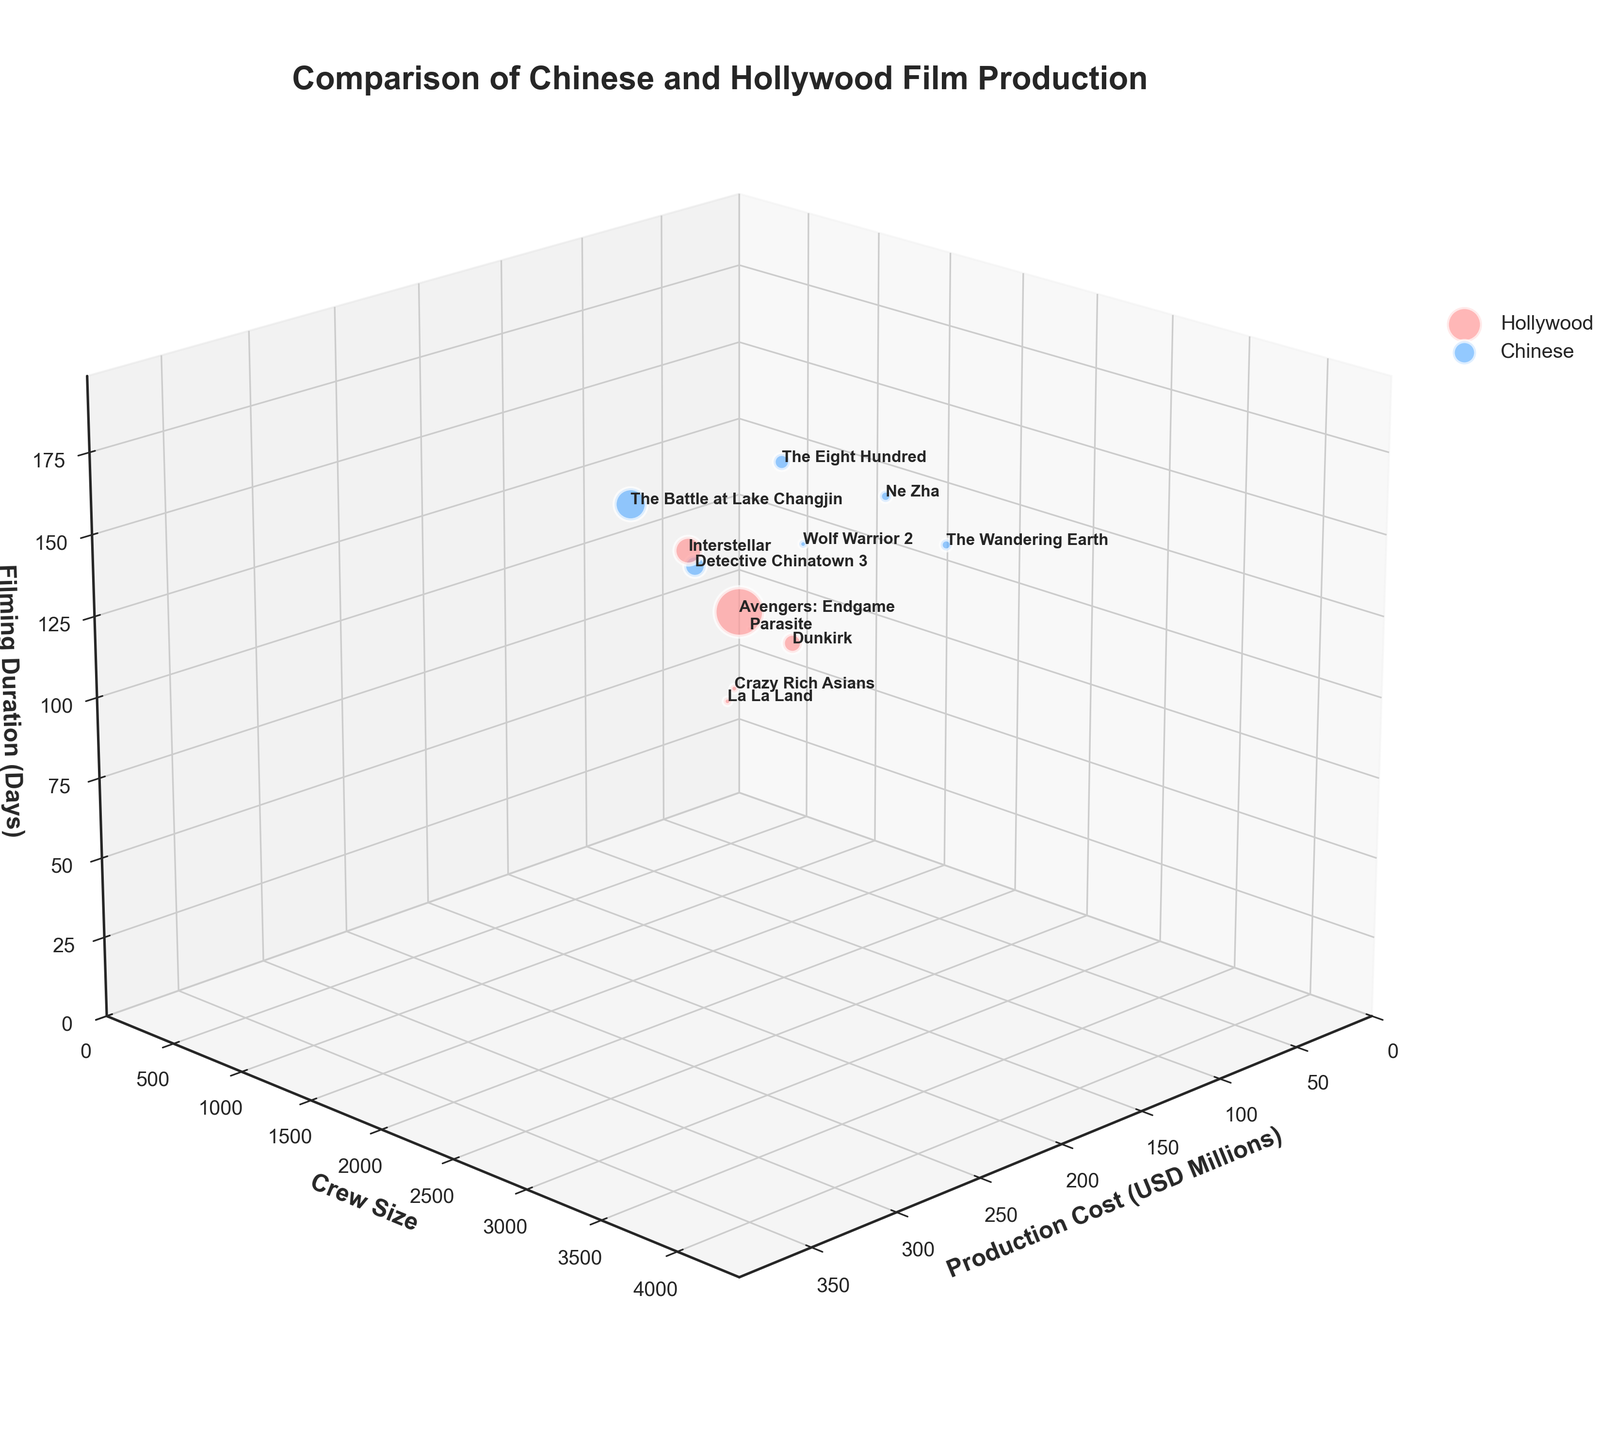What is the title of the figure? The title is usually displayed at the top of the figure. By looking at the top, we can see the title "Comparison of Chinese and Hollywood Film Production".
Answer: Comparison of Chinese and Hollywood Film Production What do the axes represent? Each of the three axes is labeled with their respective dimensions, visible at their bases or along the lines. The x-axis is labeled "Production Cost (USD Millions)", the y-axis is labeled "Crew Size", and the z-axis is labeled "Filming Duration (Days)".
Answer: Production Cost (USD Millions), Crew Size, Filming Duration (Days) How many bubbles represent Hollywood films? The number of data points (bubbles) can be counted based on the color that represents Hollywood films. The Hollywood films are represented by one specific color, and there are 6 such bubbles.
Answer: 6 Which film has the highest production cost? To determine the film with the highest production cost, identify the largest x-axis value among the bubbles. "Avengers: Endgame" has the highest value on the x-axis at 356 USD Millions.
Answer: Avengers: Endgame What is the crew size for "The Wandering Earth"? Locate the bubble labeled "The Wandering Earth" and reference its y-axis position. The label next to this bubble indicates it has a crew size of 2000.
Answer: 2000 How does the crew size of "Dunkirk" compare to "Crazy Rich Asians"? Locate the bubbles for "Dunkirk" and "Crazy Rich Asians" and compare their y-axis positions. "Dunkirk" has a crew size of 1500, and "Crazy Rich Asians" has a crew size of 300.
Answer: "Dunkirk" has a larger crew size than "Crazy Rich Asians" What is the average filming duration of all Chinese films? Identify all Chinese films and sum their filming durations (120 + 150 + 130 + 140 + 100 + 110 = 750). Divide this sum by the number of Chinese films (6). So, the average is 750/6 = 125.
Answer: 125 days Which film has the largest bubble size, and what does that signify? The size of the bubble corresponds to the production cost. The largest bubble belongs to "Avengers: Endgame", indicating it has the highest production cost among the films.
Answer: Avengers: Endgame; Highest Production Cost Which film in the Hollywood industry has the shortest filming duration? Find the Hollywood film bubble with the smallest value on the z-axis. "La La Land" has the shortest filming duration with a value of 40 days in the Hollywood industry.
Answer: La La Land How does the production cost of "The Eight Hundred" compare to "Interstellar"? Locate the bubbles for "The Eight Hundred" and "Interstellar" and compare their x-axis positions. "The Eight Hundred" has a production cost of 80 USD Millions, while "Interstellar" has a production cost of 165 USD Millions.
Answer: "The Eight Hundred" has a lower production cost than "Interstellar" 